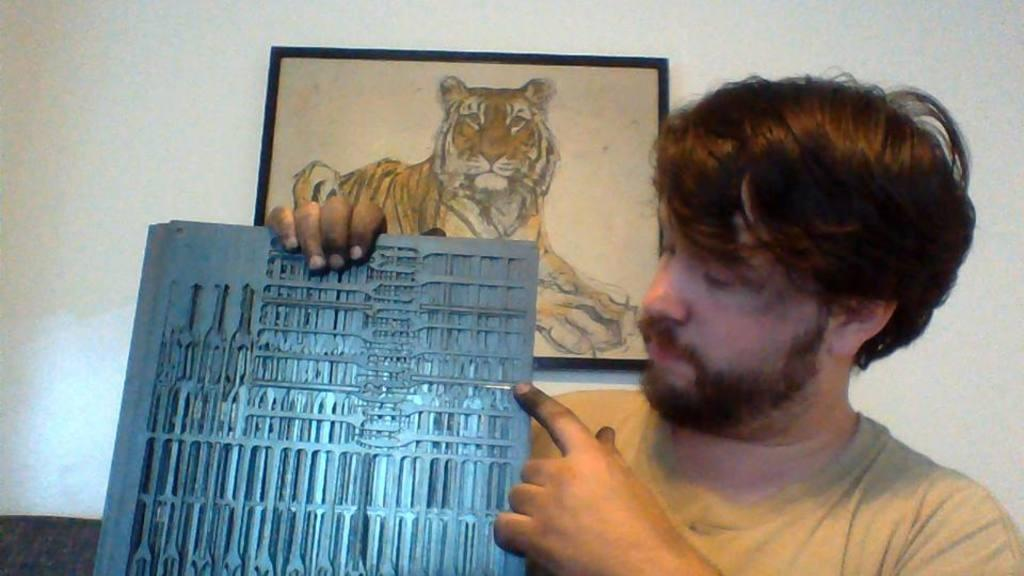What is present in the image? There is a person in the image. What is the person holding in their hand? The person is holding an object in their hand. What can be seen in the background of the image? There is a wall and a photo frame in the background of the image. Can you describe the setting of the image? The image may have been taken in a room. What type of train can be seen in the image? There is no train present in the image. How does the person use the comb in the image? There is no comb present in the image. 